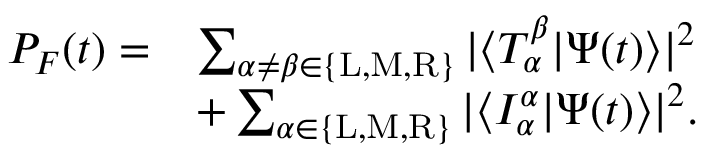Convert formula to latex. <formula><loc_0><loc_0><loc_500><loc_500>\begin{array} { r l } { P _ { F } ( t ) = } & { \sum _ { \alpha \neq \beta \in \{ L , M , R \} } | \langle T _ { \alpha } ^ { \beta } | \Psi ( t ) \rangle | ^ { 2 } } \\ & { + \sum _ { \alpha \in \{ L , M , R \} } | \langle I _ { \alpha } ^ { \alpha } | \Psi ( t ) \rangle | ^ { 2 } . } \end{array}</formula> 